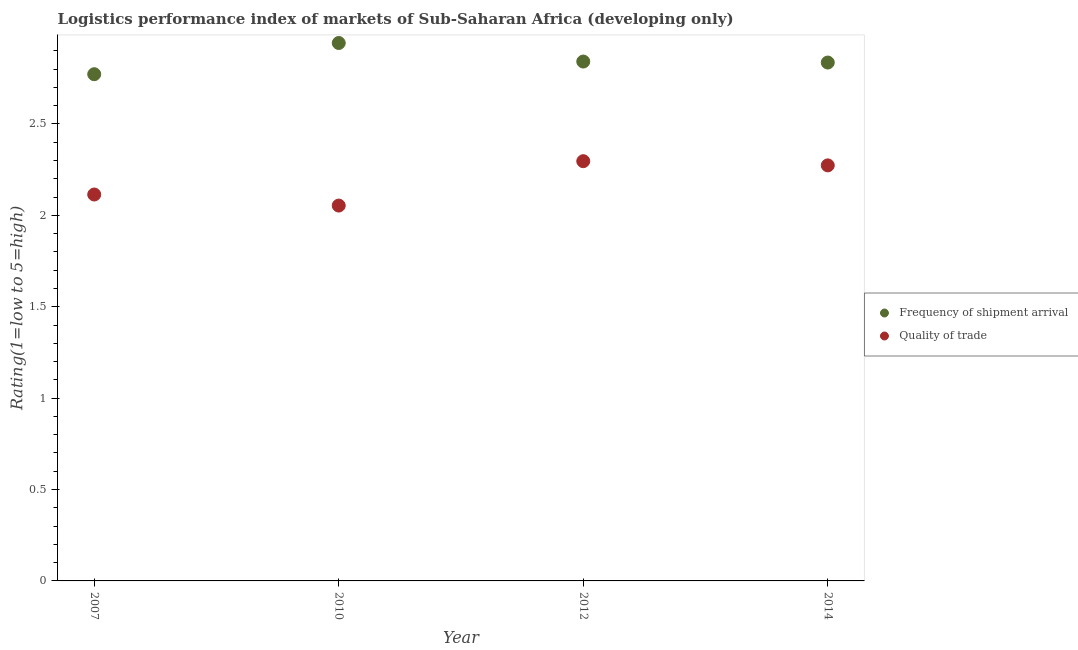How many different coloured dotlines are there?
Ensure brevity in your answer.  2. What is the lpi of frequency of shipment arrival in 2010?
Offer a very short reply. 2.94. Across all years, what is the maximum lpi of frequency of shipment arrival?
Offer a very short reply. 2.94. Across all years, what is the minimum lpi quality of trade?
Provide a succinct answer. 2.05. What is the total lpi quality of trade in the graph?
Your answer should be very brief. 8.74. What is the difference between the lpi quality of trade in 2007 and that in 2012?
Your answer should be very brief. -0.18. What is the difference between the lpi quality of trade in 2014 and the lpi of frequency of shipment arrival in 2012?
Ensure brevity in your answer.  -0.57. What is the average lpi quality of trade per year?
Your response must be concise. 2.18. In the year 2010, what is the difference between the lpi quality of trade and lpi of frequency of shipment arrival?
Offer a terse response. -0.89. In how many years, is the lpi of frequency of shipment arrival greater than 0.1?
Provide a succinct answer. 4. What is the ratio of the lpi of frequency of shipment arrival in 2010 to that in 2012?
Keep it short and to the point. 1.04. What is the difference between the highest and the second highest lpi quality of trade?
Make the answer very short. 0.02. What is the difference between the highest and the lowest lpi quality of trade?
Ensure brevity in your answer.  0.24. In how many years, is the lpi of frequency of shipment arrival greater than the average lpi of frequency of shipment arrival taken over all years?
Keep it short and to the point. 1. Does the lpi quality of trade monotonically increase over the years?
Make the answer very short. No. Is the lpi quality of trade strictly greater than the lpi of frequency of shipment arrival over the years?
Your answer should be very brief. No. Is the lpi quality of trade strictly less than the lpi of frequency of shipment arrival over the years?
Your answer should be very brief. Yes. How many dotlines are there?
Give a very brief answer. 2. What is the difference between two consecutive major ticks on the Y-axis?
Offer a very short reply. 0.5. Does the graph contain any zero values?
Provide a succinct answer. No. What is the title of the graph?
Offer a terse response. Logistics performance index of markets of Sub-Saharan Africa (developing only). Does "Private funds" appear as one of the legend labels in the graph?
Make the answer very short. No. What is the label or title of the X-axis?
Your answer should be compact. Year. What is the label or title of the Y-axis?
Offer a very short reply. Rating(1=low to 5=high). What is the Rating(1=low to 5=high) in Frequency of shipment arrival in 2007?
Keep it short and to the point. 2.77. What is the Rating(1=low to 5=high) of Quality of trade in 2007?
Provide a short and direct response. 2.11. What is the Rating(1=low to 5=high) of Frequency of shipment arrival in 2010?
Provide a succinct answer. 2.94. What is the Rating(1=low to 5=high) in Quality of trade in 2010?
Offer a very short reply. 2.05. What is the Rating(1=low to 5=high) in Frequency of shipment arrival in 2012?
Your answer should be compact. 2.84. What is the Rating(1=low to 5=high) of Quality of trade in 2012?
Give a very brief answer. 2.3. What is the Rating(1=low to 5=high) in Frequency of shipment arrival in 2014?
Your response must be concise. 2.84. What is the Rating(1=low to 5=high) of Quality of trade in 2014?
Provide a short and direct response. 2.27. Across all years, what is the maximum Rating(1=low to 5=high) of Frequency of shipment arrival?
Keep it short and to the point. 2.94. Across all years, what is the maximum Rating(1=low to 5=high) in Quality of trade?
Offer a very short reply. 2.3. Across all years, what is the minimum Rating(1=low to 5=high) of Frequency of shipment arrival?
Ensure brevity in your answer.  2.77. Across all years, what is the minimum Rating(1=low to 5=high) in Quality of trade?
Provide a short and direct response. 2.05. What is the total Rating(1=low to 5=high) in Frequency of shipment arrival in the graph?
Provide a succinct answer. 11.39. What is the total Rating(1=low to 5=high) of Quality of trade in the graph?
Ensure brevity in your answer.  8.74. What is the difference between the Rating(1=low to 5=high) of Frequency of shipment arrival in 2007 and that in 2010?
Offer a terse response. -0.17. What is the difference between the Rating(1=low to 5=high) of Quality of trade in 2007 and that in 2010?
Offer a very short reply. 0.06. What is the difference between the Rating(1=low to 5=high) of Frequency of shipment arrival in 2007 and that in 2012?
Offer a very short reply. -0.07. What is the difference between the Rating(1=low to 5=high) of Quality of trade in 2007 and that in 2012?
Keep it short and to the point. -0.18. What is the difference between the Rating(1=low to 5=high) in Frequency of shipment arrival in 2007 and that in 2014?
Provide a short and direct response. -0.06. What is the difference between the Rating(1=low to 5=high) of Quality of trade in 2007 and that in 2014?
Make the answer very short. -0.16. What is the difference between the Rating(1=low to 5=high) in Frequency of shipment arrival in 2010 and that in 2012?
Your answer should be very brief. 0.1. What is the difference between the Rating(1=low to 5=high) of Quality of trade in 2010 and that in 2012?
Your answer should be very brief. -0.24. What is the difference between the Rating(1=low to 5=high) in Frequency of shipment arrival in 2010 and that in 2014?
Provide a succinct answer. 0.11. What is the difference between the Rating(1=low to 5=high) in Quality of trade in 2010 and that in 2014?
Offer a terse response. -0.22. What is the difference between the Rating(1=low to 5=high) in Frequency of shipment arrival in 2012 and that in 2014?
Your answer should be compact. 0.01. What is the difference between the Rating(1=low to 5=high) of Quality of trade in 2012 and that in 2014?
Provide a succinct answer. 0.02. What is the difference between the Rating(1=low to 5=high) of Frequency of shipment arrival in 2007 and the Rating(1=low to 5=high) of Quality of trade in 2010?
Offer a very short reply. 0.72. What is the difference between the Rating(1=low to 5=high) of Frequency of shipment arrival in 2007 and the Rating(1=low to 5=high) of Quality of trade in 2012?
Your answer should be compact. 0.48. What is the difference between the Rating(1=low to 5=high) of Frequency of shipment arrival in 2007 and the Rating(1=low to 5=high) of Quality of trade in 2014?
Keep it short and to the point. 0.5. What is the difference between the Rating(1=low to 5=high) in Frequency of shipment arrival in 2010 and the Rating(1=low to 5=high) in Quality of trade in 2012?
Provide a succinct answer. 0.65. What is the difference between the Rating(1=low to 5=high) of Frequency of shipment arrival in 2010 and the Rating(1=low to 5=high) of Quality of trade in 2014?
Offer a terse response. 0.67. What is the difference between the Rating(1=low to 5=high) of Frequency of shipment arrival in 2012 and the Rating(1=low to 5=high) of Quality of trade in 2014?
Give a very brief answer. 0.57. What is the average Rating(1=low to 5=high) of Frequency of shipment arrival per year?
Provide a succinct answer. 2.85. What is the average Rating(1=low to 5=high) of Quality of trade per year?
Make the answer very short. 2.18. In the year 2007, what is the difference between the Rating(1=low to 5=high) in Frequency of shipment arrival and Rating(1=low to 5=high) in Quality of trade?
Provide a short and direct response. 0.66. In the year 2010, what is the difference between the Rating(1=low to 5=high) in Frequency of shipment arrival and Rating(1=low to 5=high) in Quality of trade?
Ensure brevity in your answer.  0.89. In the year 2012, what is the difference between the Rating(1=low to 5=high) in Frequency of shipment arrival and Rating(1=low to 5=high) in Quality of trade?
Ensure brevity in your answer.  0.55. In the year 2014, what is the difference between the Rating(1=low to 5=high) of Frequency of shipment arrival and Rating(1=low to 5=high) of Quality of trade?
Ensure brevity in your answer.  0.56. What is the ratio of the Rating(1=low to 5=high) of Frequency of shipment arrival in 2007 to that in 2010?
Provide a short and direct response. 0.94. What is the ratio of the Rating(1=low to 5=high) in Quality of trade in 2007 to that in 2010?
Give a very brief answer. 1.03. What is the ratio of the Rating(1=low to 5=high) in Frequency of shipment arrival in 2007 to that in 2012?
Offer a terse response. 0.98. What is the ratio of the Rating(1=low to 5=high) in Quality of trade in 2007 to that in 2012?
Provide a succinct answer. 0.92. What is the ratio of the Rating(1=low to 5=high) in Frequency of shipment arrival in 2007 to that in 2014?
Your response must be concise. 0.98. What is the ratio of the Rating(1=low to 5=high) in Quality of trade in 2007 to that in 2014?
Give a very brief answer. 0.93. What is the ratio of the Rating(1=low to 5=high) in Frequency of shipment arrival in 2010 to that in 2012?
Offer a terse response. 1.04. What is the ratio of the Rating(1=low to 5=high) in Quality of trade in 2010 to that in 2012?
Your answer should be compact. 0.89. What is the ratio of the Rating(1=low to 5=high) in Frequency of shipment arrival in 2010 to that in 2014?
Your response must be concise. 1.04. What is the ratio of the Rating(1=low to 5=high) of Quality of trade in 2010 to that in 2014?
Provide a short and direct response. 0.9. What is the ratio of the Rating(1=low to 5=high) of Frequency of shipment arrival in 2012 to that in 2014?
Offer a very short reply. 1. What is the ratio of the Rating(1=low to 5=high) of Quality of trade in 2012 to that in 2014?
Your answer should be very brief. 1.01. What is the difference between the highest and the second highest Rating(1=low to 5=high) in Frequency of shipment arrival?
Your response must be concise. 0.1. What is the difference between the highest and the second highest Rating(1=low to 5=high) in Quality of trade?
Give a very brief answer. 0.02. What is the difference between the highest and the lowest Rating(1=low to 5=high) of Frequency of shipment arrival?
Offer a terse response. 0.17. What is the difference between the highest and the lowest Rating(1=low to 5=high) of Quality of trade?
Provide a short and direct response. 0.24. 